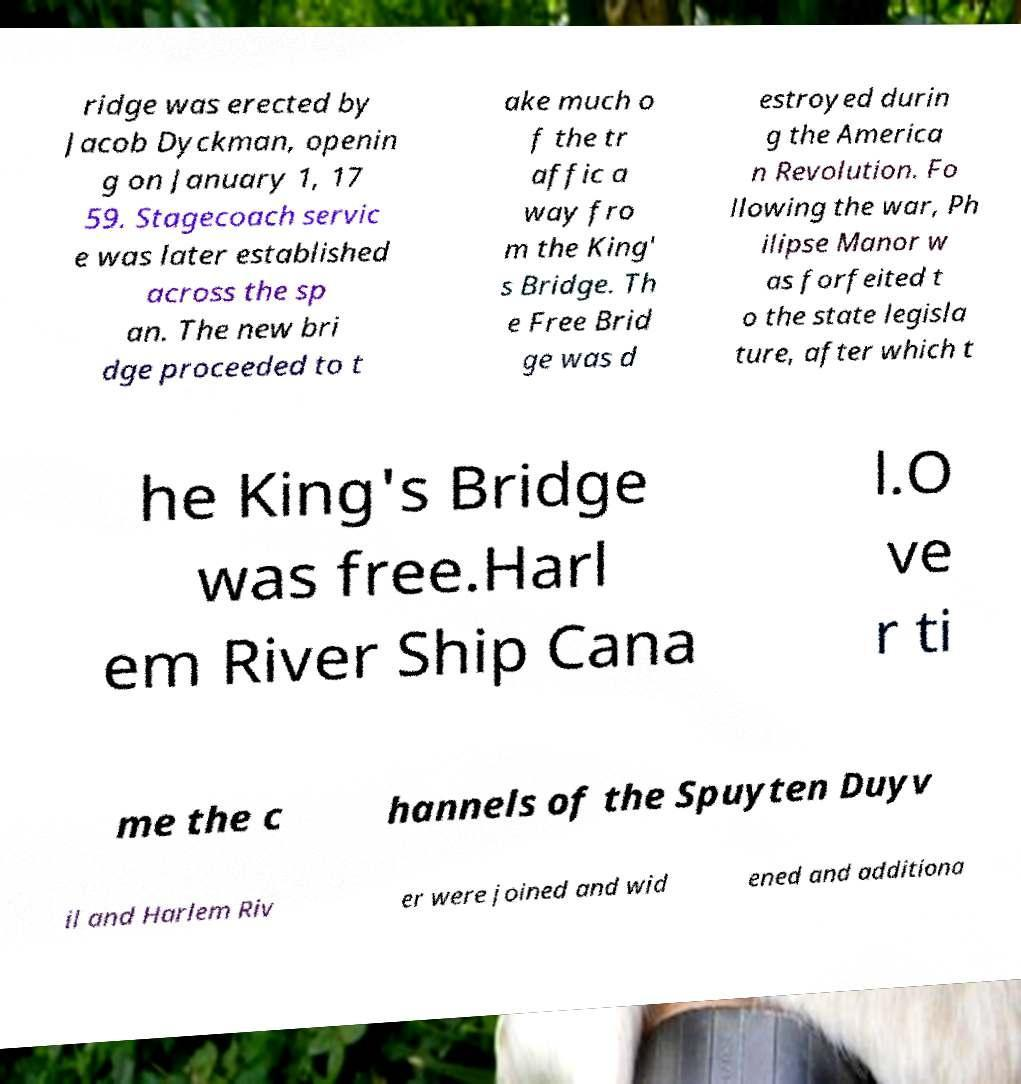Please read and relay the text visible in this image. What does it say? ridge was erected by Jacob Dyckman, openin g on January 1, 17 59. Stagecoach servic e was later established across the sp an. The new bri dge proceeded to t ake much o f the tr affic a way fro m the King' s Bridge. Th e Free Brid ge was d estroyed durin g the America n Revolution. Fo llowing the war, Ph ilipse Manor w as forfeited t o the state legisla ture, after which t he King's Bridge was free.Harl em River Ship Cana l.O ve r ti me the c hannels of the Spuyten Duyv il and Harlem Riv er were joined and wid ened and additiona 